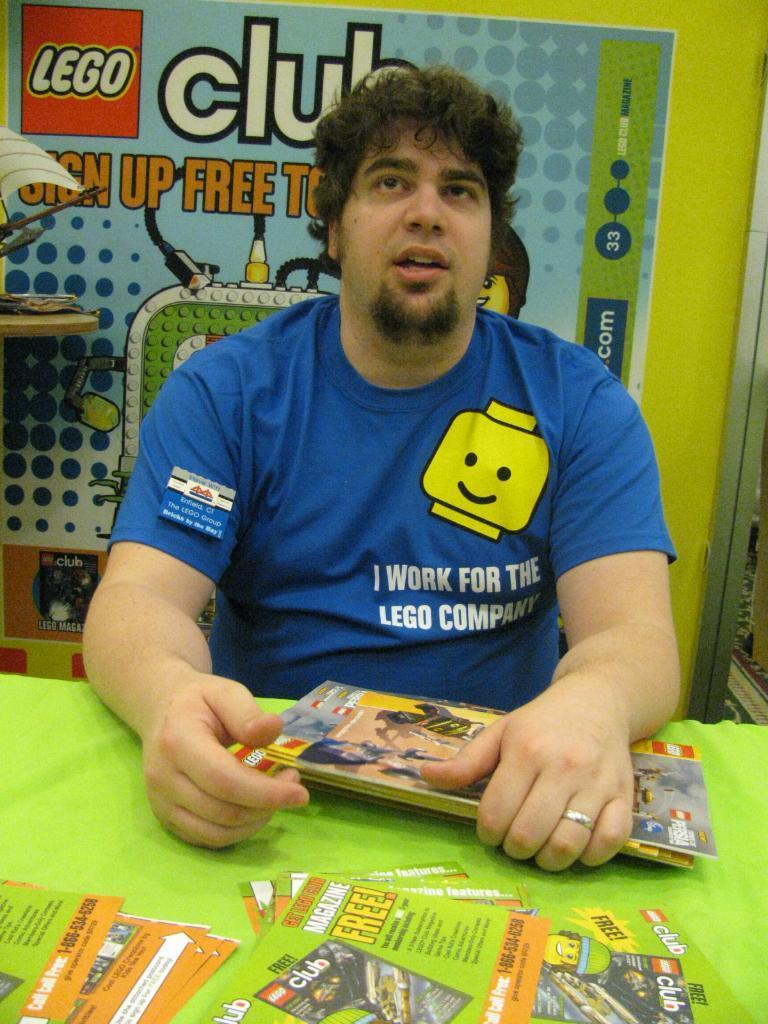Can you describe this image briefly? There is a man sitting and holding books, in front of him we can see books and posters on the table, behind him we can see objects on the table and poster on the green surface. 